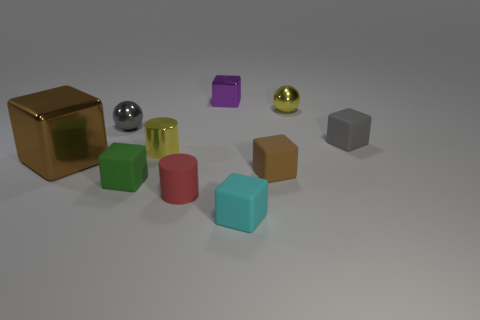Subtract all small metal blocks. How many blocks are left? 5 Subtract all gray blocks. How many blocks are left? 5 Subtract all blue balls. How many brown blocks are left? 2 Subtract all cylinders. How many objects are left? 8 Subtract all large gray things. Subtract all tiny brown rubber things. How many objects are left? 9 Add 2 tiny gray objects. How many tiny gray objects are left? 4 Add 8 shiny balls. How many shiny balls exist? 10 Subtract 1 cyan blocks. How many objects are left? 9 Subtract 2 cylinders. How many cylinders are left? 0 Subtract all green blocks. Subtract all green cylinders. How many blocks are left? 5 